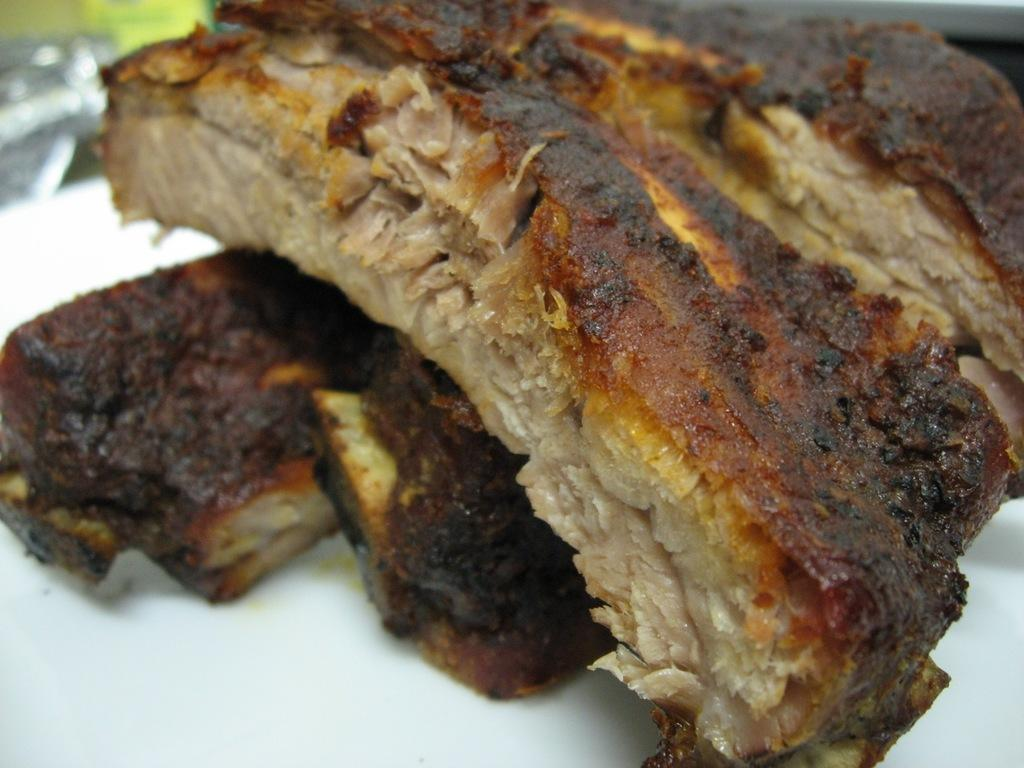What type of food is on the plate in the image? There are grilled pieces of meat on a plate in the image. What type of guitar is being played in the image? There is no guitar present in the image; it only features grilled pieces of meat on a plate. 